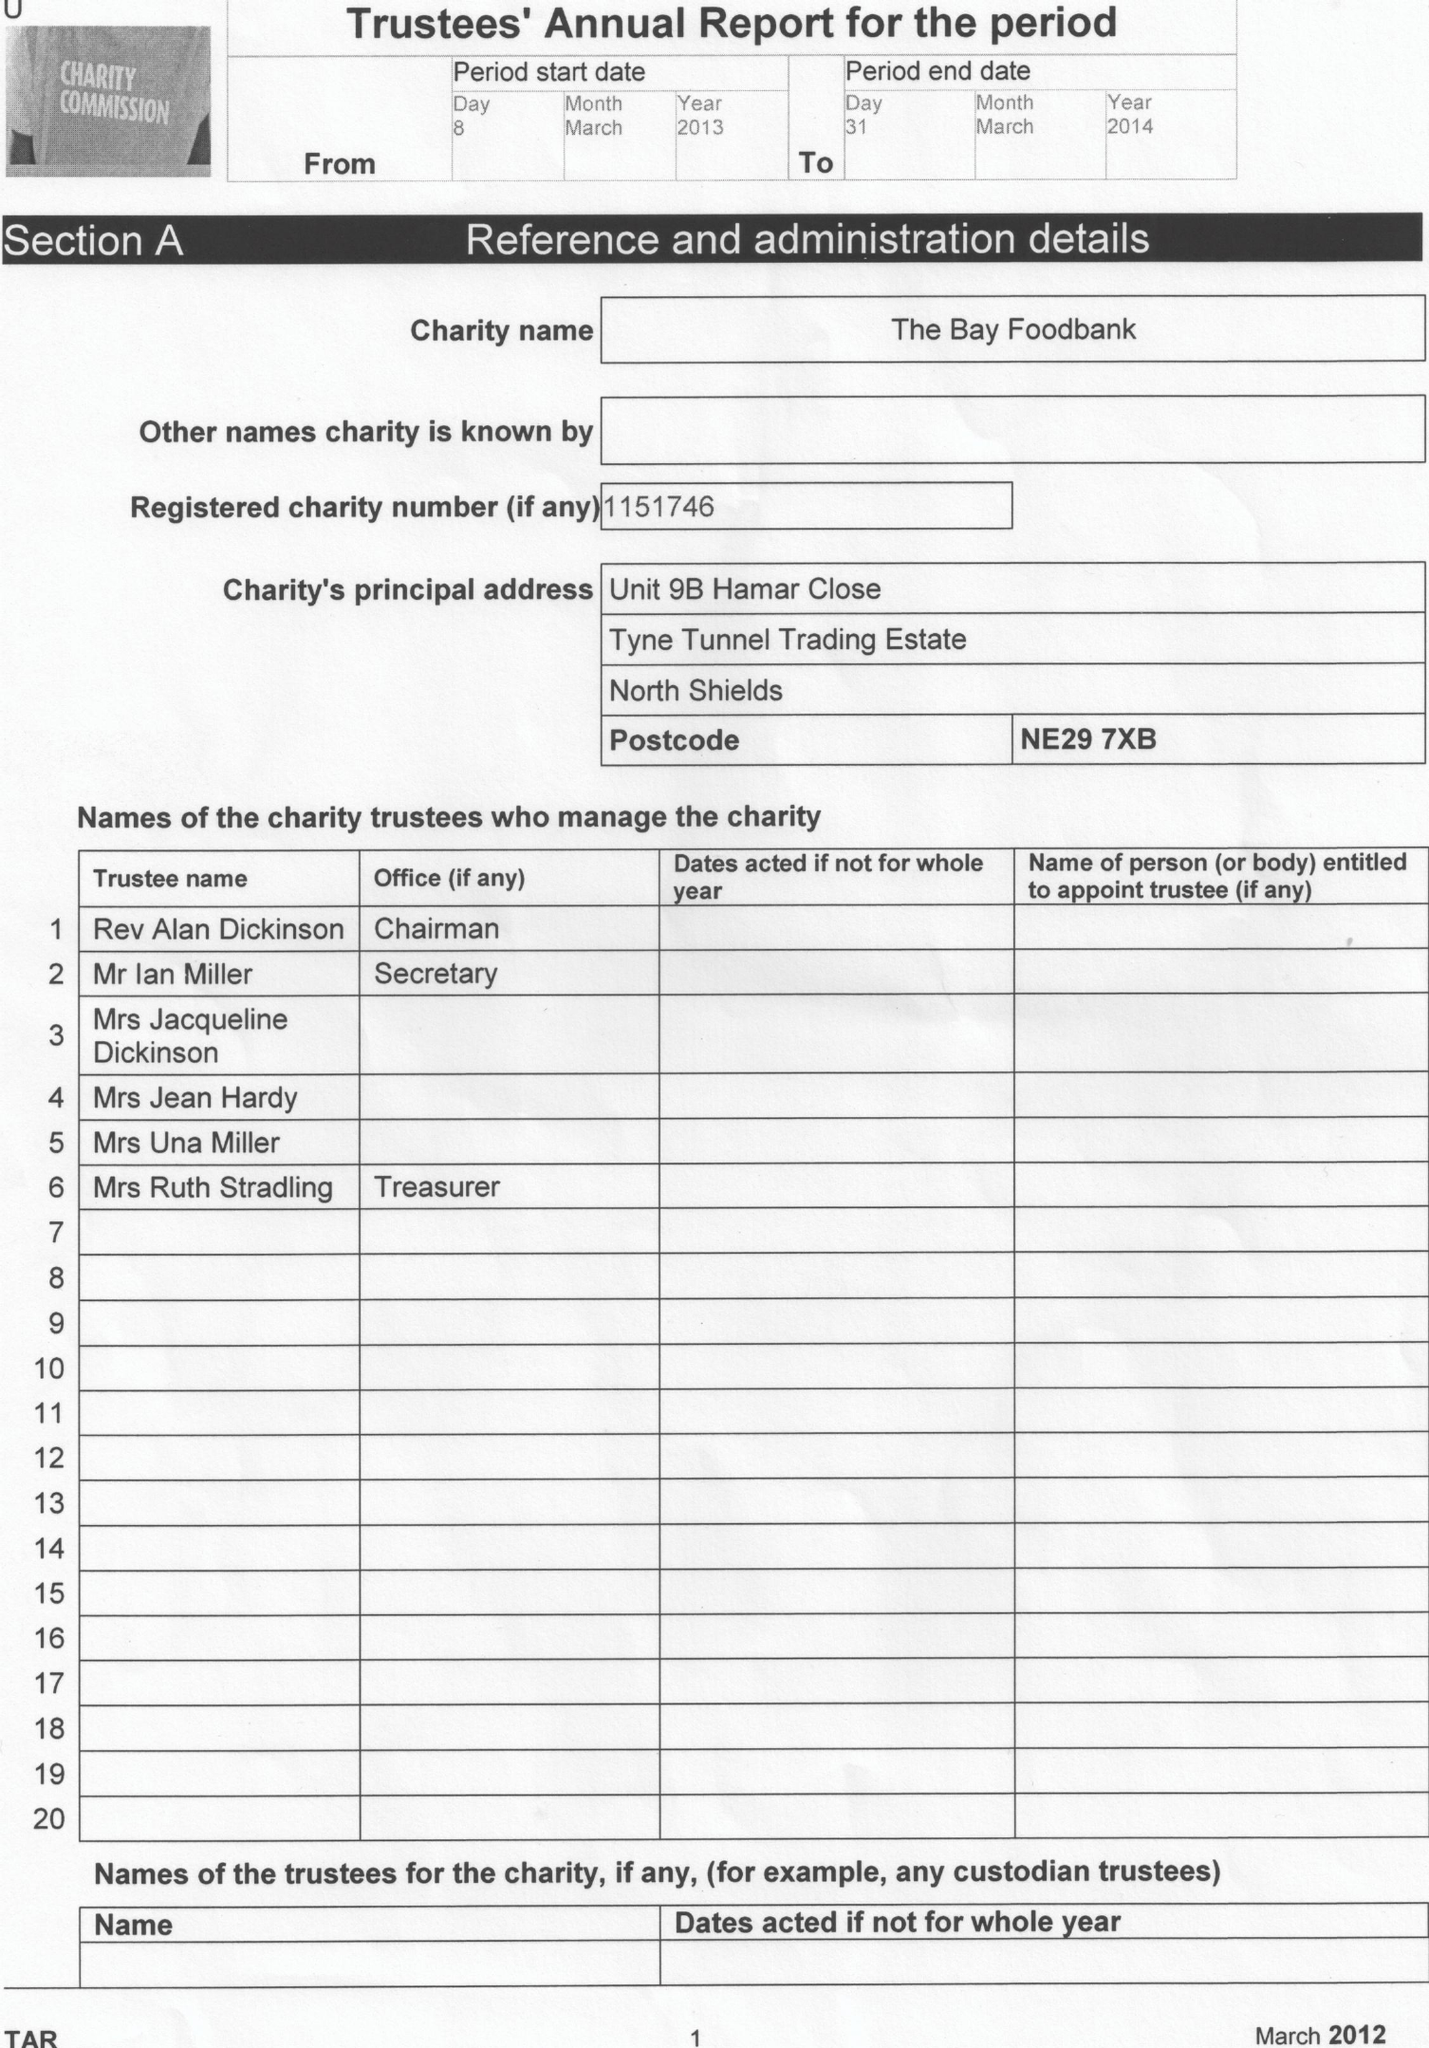What is the value for the charity_name?
Answer the question using a single word or phrase. The Bay Foodbank 